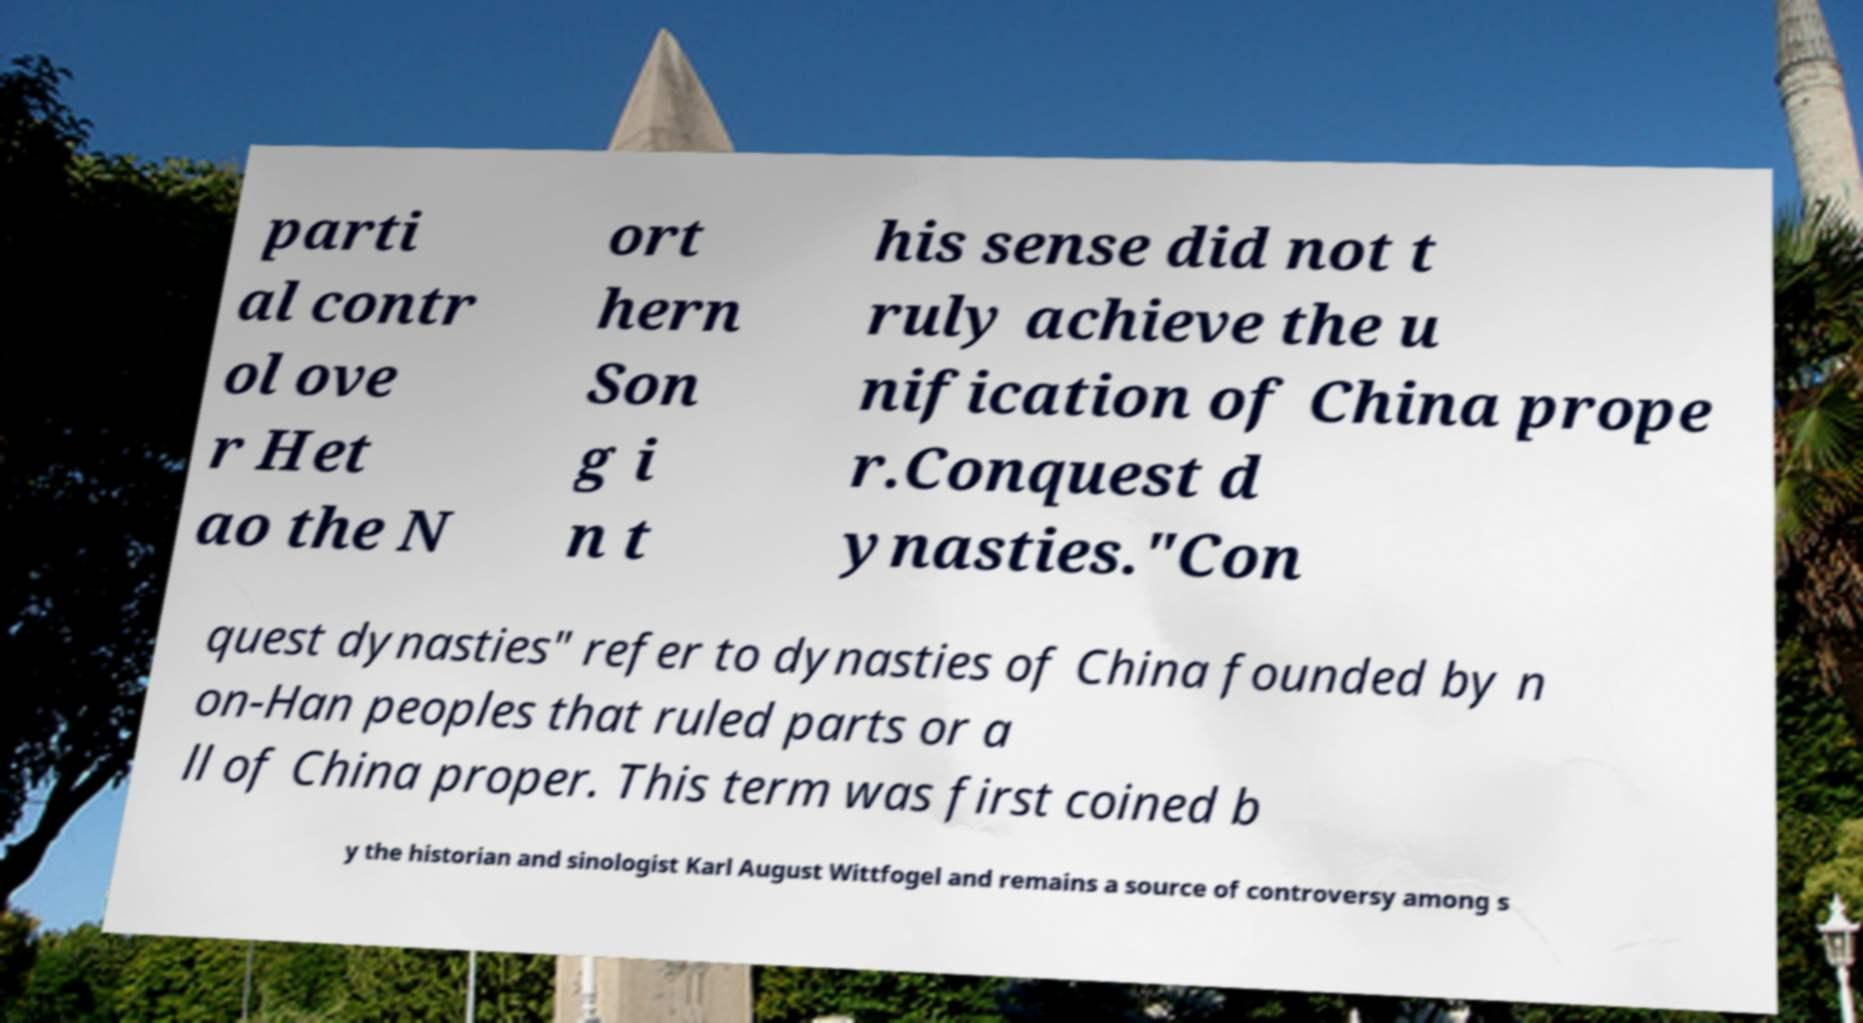Could you assist in decoding the text presented in this image and type it out clearly? parti al contr ol ove r Het ao the N ort hern Son g i n t his sense did not t ruly achieve the u nification of China prope r.Conquest d ynasties."Con quest dynasties" refer to dynasties of China founded by n on-Han peoples that ruled parts or a ll of China proper. This term was first coined b y the historian and sinologist Karl August Wittfogel and remains a source of controversy among s 